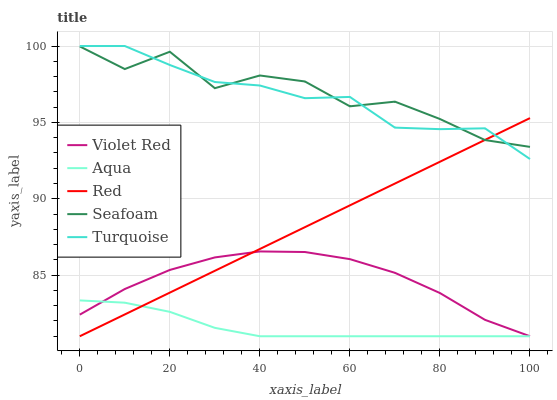Does Aqua have the minimum area under the curve?
Answer yes or no. Yes. Does Seafoam have the maximum area under the curve?
Answer yes or no. Yes. Does Turquoise have the minimum area under the curve?
Answer yes or no. No. Does Turquoise have the maximum area under the curve?
Answer yes or no. No. Is Red the smoothest?
Answer yes or no. Yes. Is Seafoam the roughest?
Answer yes or no. Yes. Is Turquoise the smoothest?
Answer yes or no. No. Is Turquoise the roughest?
Answer yes or no. No. Does Turquoise have the lowest value?
Answer yes or no. No. Does Turquoise have the highest value?
Answer yes or no. Yes. Does Aqua have the highest value?
Answer yes or no. No. Is Violet Red less than Seafoam?
Answer yes or no. Yes. Is Seafoam greater than Violet Red?
Answer yes or no. Yes. Does Aqua intersect Red?
Answer yes or no. Yes. Is Aqua less than Red?
Answer yes or no. No. Is Aqua greater than Red?
Answer yes or no. No. Does Violet Red intersect Seafoam?
Answer yes or no. No. 